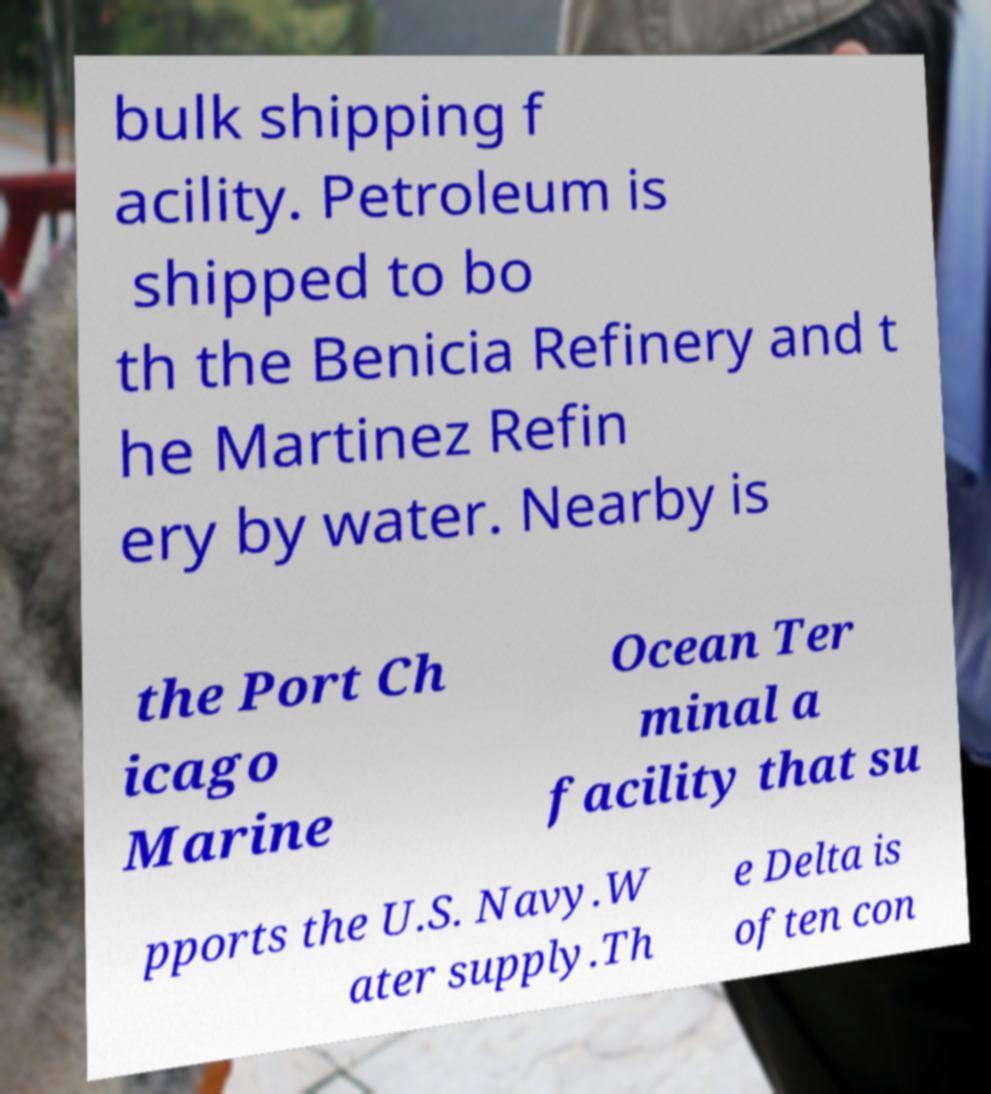Can you accurately transcribe the text from the provided image for me? bulk shipping f acility. Petroleum is shipped to bo th the Benicia Refinery and t he Martinez Refin ery by water. Nearby is the Port Ch icago Marine Ocean Ter minal a facility that su pports the U.S. Navy.W ater supply.Th e Delta is often con 